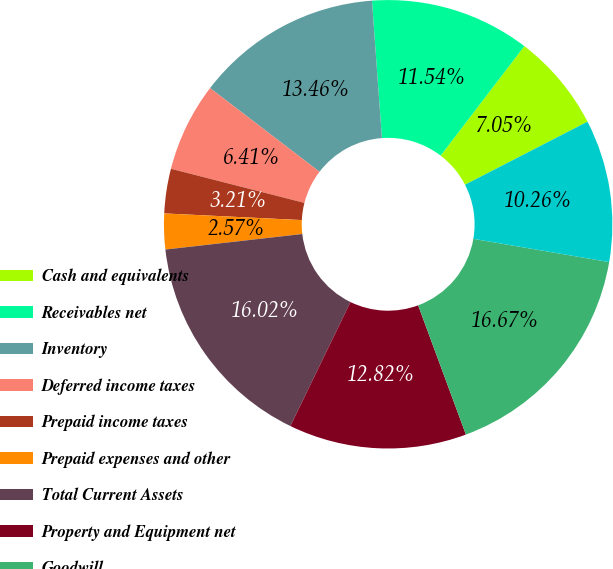Convert chart to OTSL. <chart><loc_0><loc_0><loc_500><loc_500><pie_chart><fcel>Cash and equivalents<fcel>Receivables net<fcel>Inventory<fcel>Deferred income taxes<fcel>Prepaid income taxes<fcel>Prepaid expenses and other<fcel>Total Current Assets<fcel>Property and Equipment net<fcel>Goodwill<fcel>Other intangibles net<nl><fcel>7.05%<fcel>11.54%<fcel>13.46%<fcel>6.41%<fcel>3.21%<fcel>2.57%<fcel>16.02%<fcel>12.82%<fcel>16.67%<fcel>10.26%<nl></chart> 